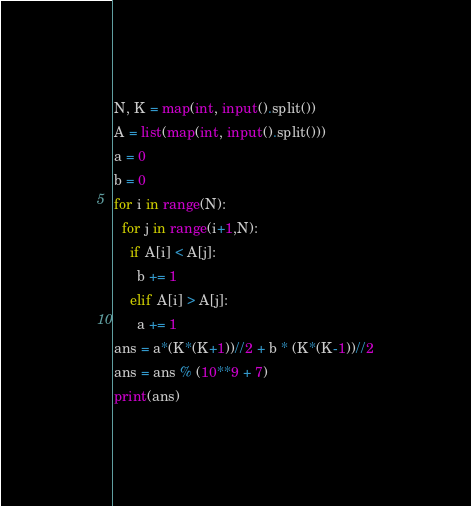Convert code to text. <code><loc_0><loc_0><loc_500><loc_500><_Python_>N, K = map(int, input().split())
A = list(map(int, input().split()))
a = 0
b = 0
for i in range(N):
  for j in range(i+1,N):
    if A[i] < A[j]:
      b += 1
    elif A[i] > A[j]:
      a += 1
ans = a*(K*(K+1))//2 + b * (K*(K-1))//2
ans = ans % (10**9 + 7)
print(ans)</code> 